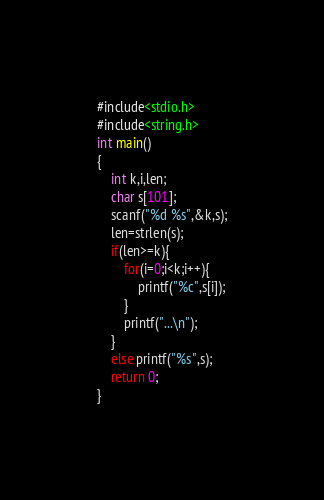Convert code to text. <code><loc_0><loc_0><loc_500><loc_500><_C_>#include<stdio.h>
#include<string.h>
int main()
{
	int k,i,len;
	char s[101];
	scanf("%d %s",&k,s);
	len=strlen(s);
	if(len>=k){
		for(i=0;i<k;i++){
			printf("%c",s[i]);
		}
		printf("...\n");
	}
	else printf("%s",s); 
	return 0;
}</code> 